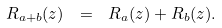<formula> <loc_0><loc_0><loc_500><loc_500>R _ { a + b } ( z ) \ = \ R _ { a } ( z ) + R _ { b } ( z ) .</formula> 